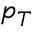Convert formula to latex. <formula><loc_0><loc_0><loc_500><loc_500>p _ { T }</formula> 